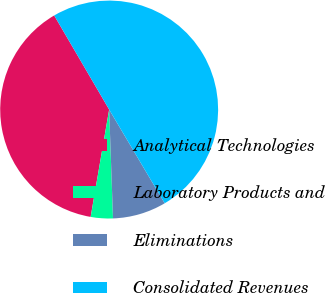<chart> <loc_0><loc_0><loc_500><loc_500><pie_chart><fcel>Analytical Technologies<fcel>Laboratory Products and<fcel>Eliminations<fcel>Consolidated Revenues<nl><fcel>38.87%<fcel>3.28%<fcel>7.95%<fcel>49.9%<nl></chart> 